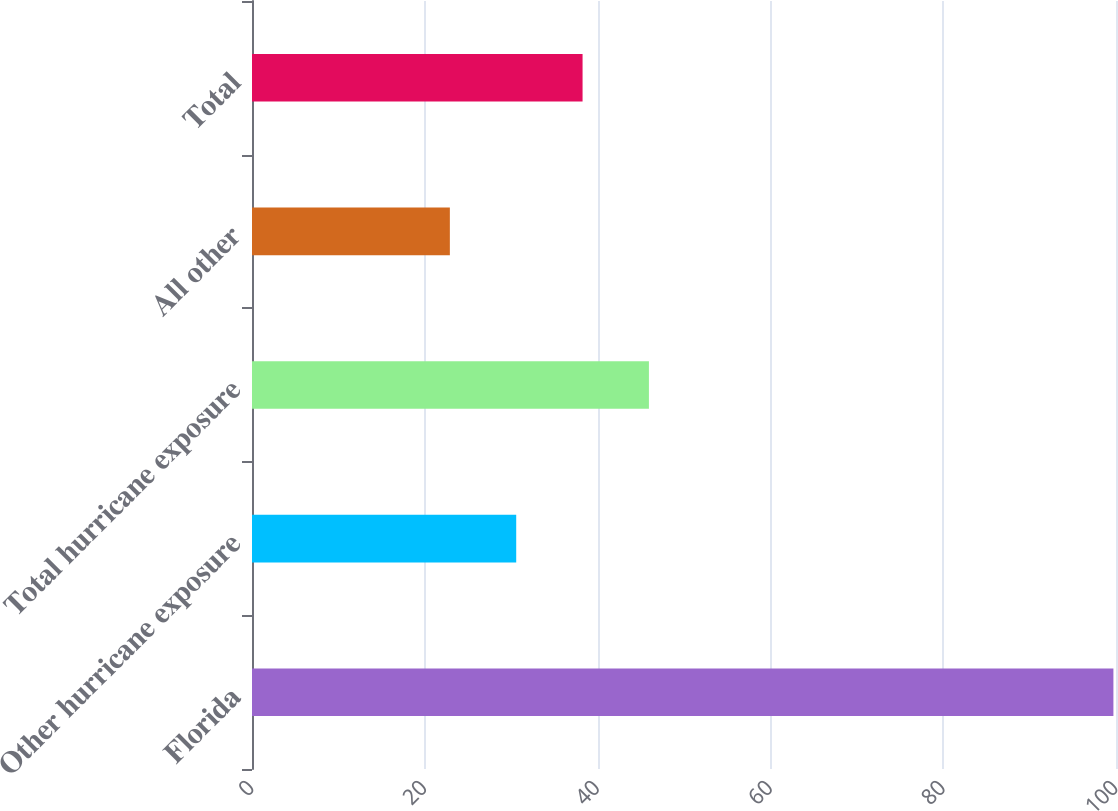Convert chart to OTSL. <chart><loc_0><loc_0><loc_500><loc_500><bar_chart><fcel>Florida<fcel>Other hurricane exposure<fcel>Total hurricane exposure<fcel>All other<fcel>Total<nl><fcel>99.7<fcel>30.58<fcel>45.94<fcel>22.9<fcel>38.26<nl></chart> 